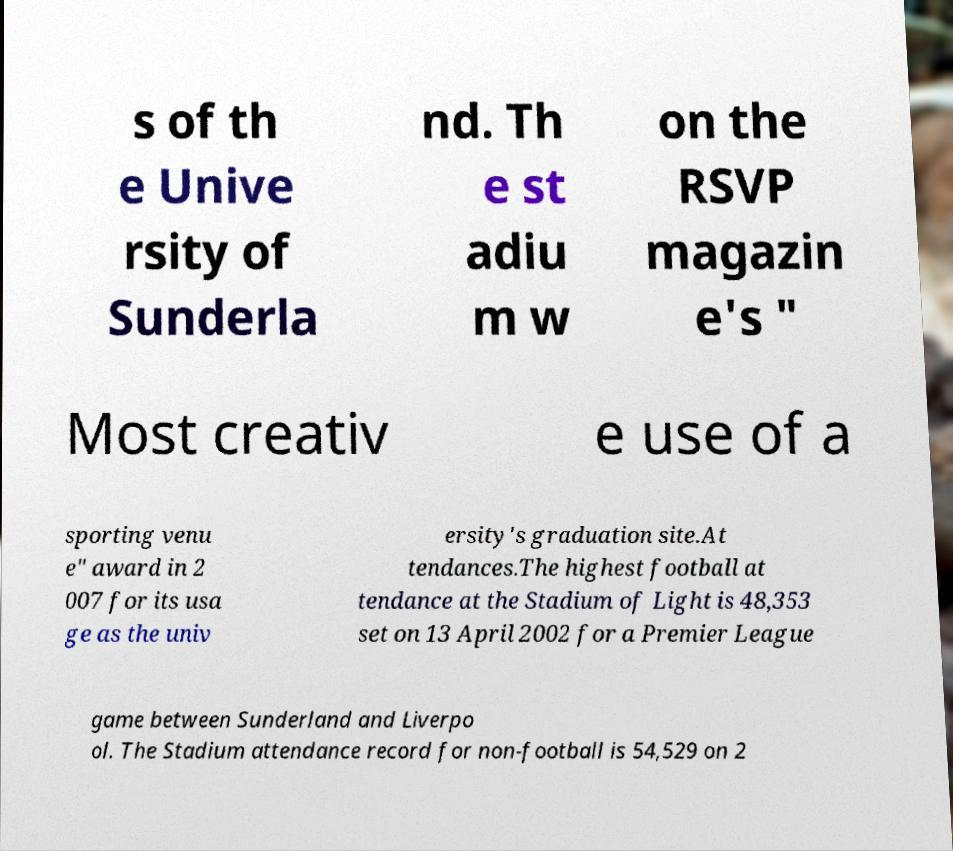Could you extract and type out the text from this image? s of th e Unive rsity of Sunderla nd. Th e st adiu m w on the RSVP magazin e's " Most creativ e use of a sporting venu e" award in 2 007 for its usa ge as the univ ersity's graduation site.At tendances.The highest football at tendance at the Stadium of Light is 48,353 set on 13 April 2002 for a Premier League game between Sunderland and Liverpo ol. The Stadium attendance record for non-football is 54,529 on 2 